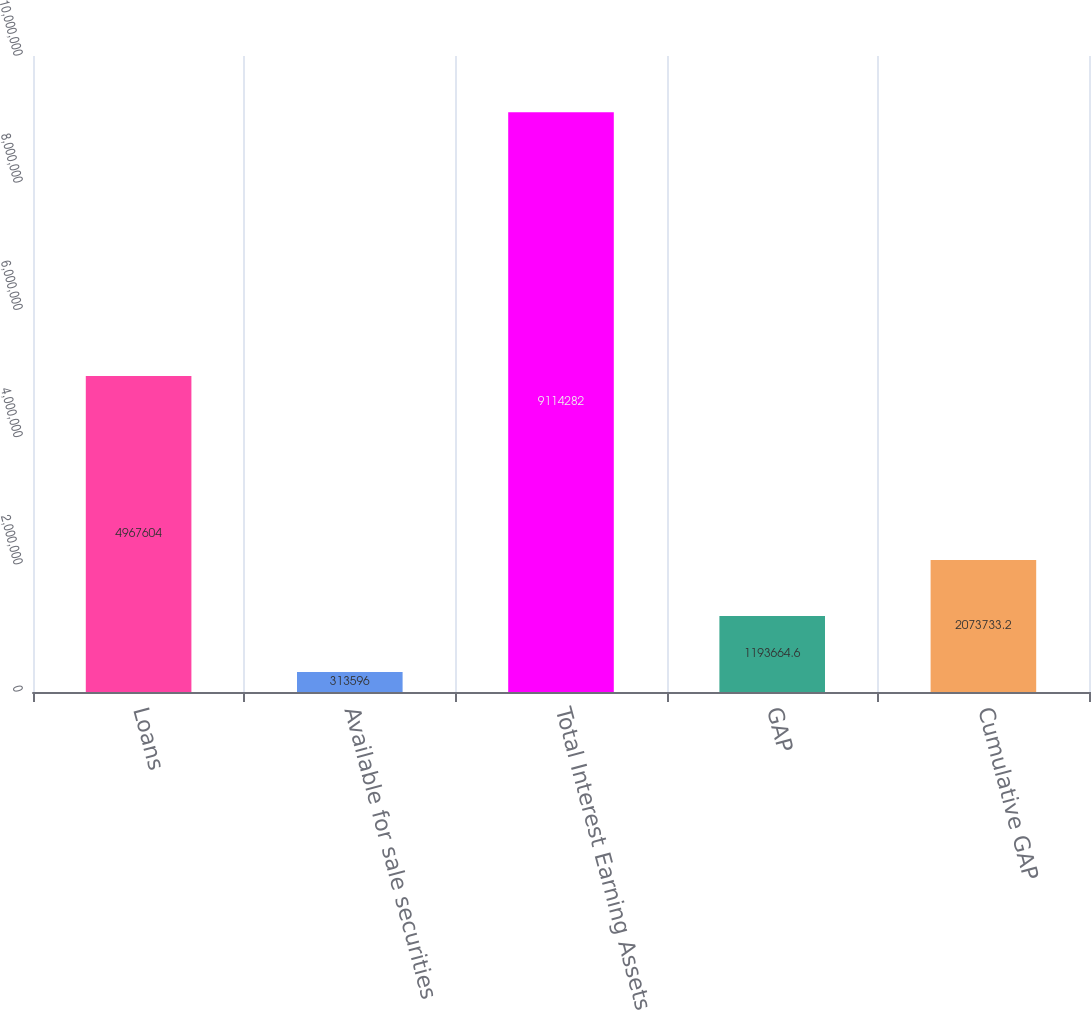Convert chart to OTSL. <chart><loc_0><loc_0><loc_500><loc_500><bar_chart><fcel>Loans<fcel>Available for sale securities<fcel>Total Interest Earning Assets<fcel>GAP<fcel>Cumulative GAP<nl><fcel>4.9676e+06<fcel>313596<fcel>9.11428e+06<fcel>1.19366e+06<fcel>2.07373e+06<nl></chart> 